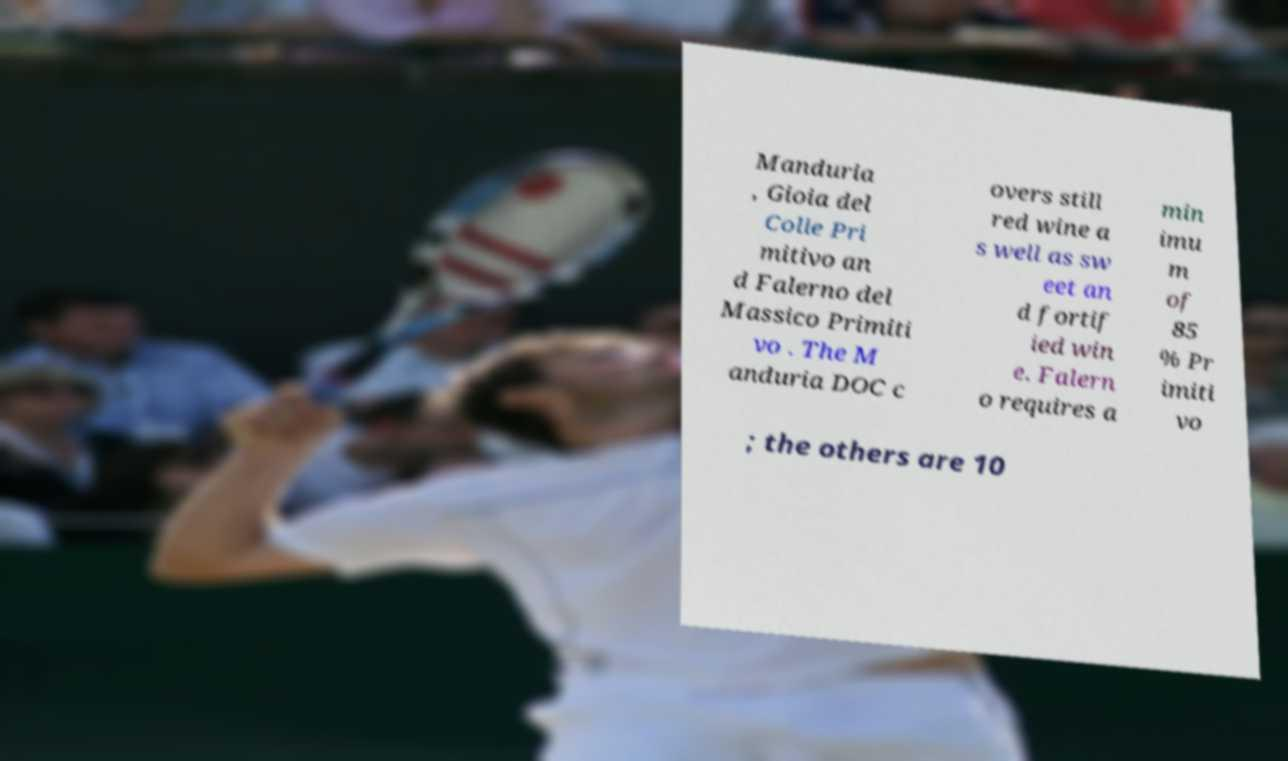Can you accurately transcribe the text from the provided image for me? Manduria , Gioia del Colle Pri mitivo an d Falerno del Massico Primiti vo . The M anduria DOC c overs still red wine a s well as sw eet an d fortif ied win e. Falern o requires a min imu m of 85 % Pr imiti vo ; the others are 10 